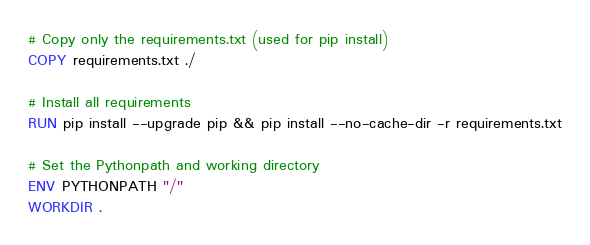Convert code to text. <code><loc_0><loc_0><loc_500><loc_500><_Dockerfile_># Copy only the requirements.txt (used for pip install)
COPY requirements.txt ./

# Install all requirements
RUN pip install --upgrade pip && pip install --no-cache-dir -r requirements.txt

# Set the Pythonpath and working directory
ENV PYTHONPATH "/"
WORKDIR .</code> 